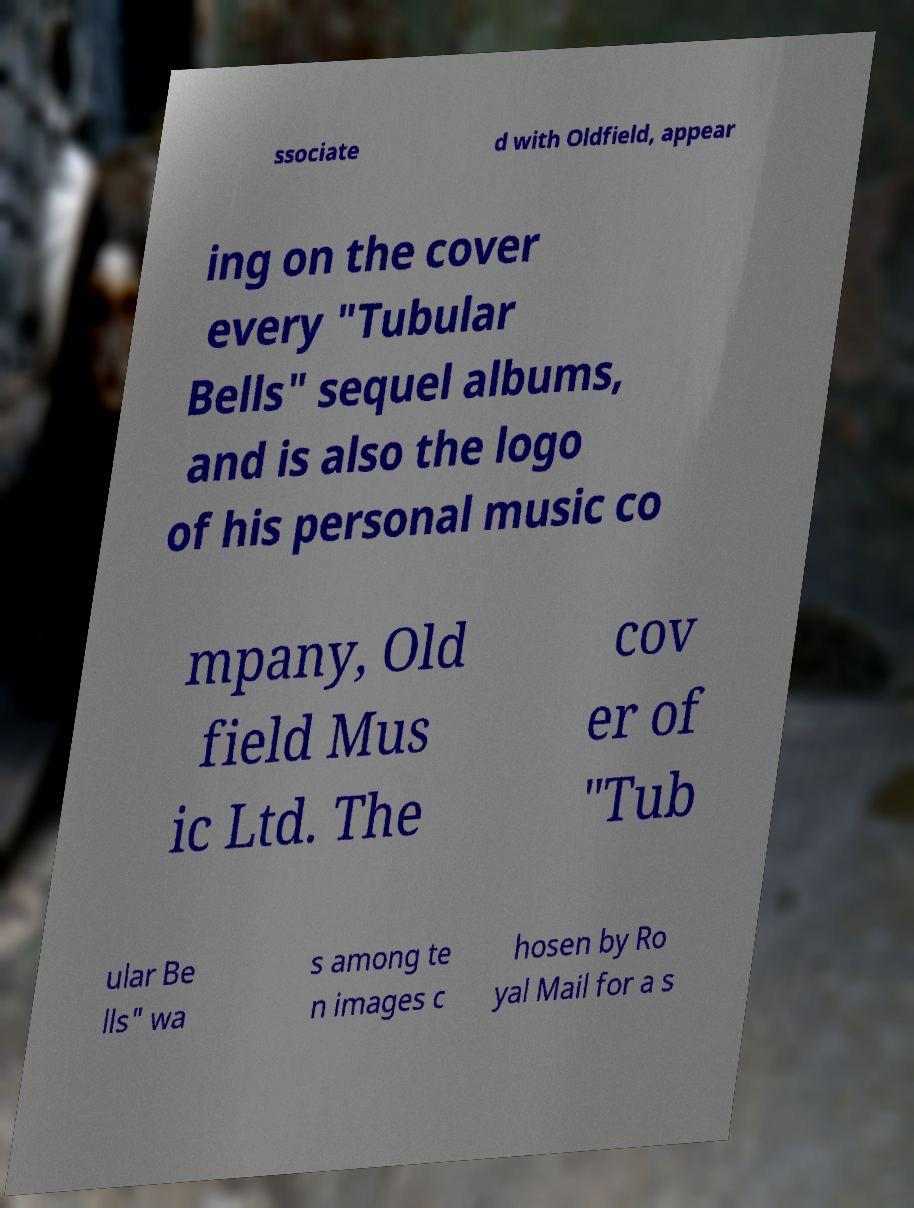What messages or text are displayed in this image? I need them in a readable, typed format. ssociate d with Oldfield, appear ing on the cover every "Tubular Bells" sequel albums, and is also the logo of his personal music co mpany, Old field Mus ic Ltd. The cov er of "Tub ular Be lls" wa s among te n images c hosen by Ro yal Mail for a s 